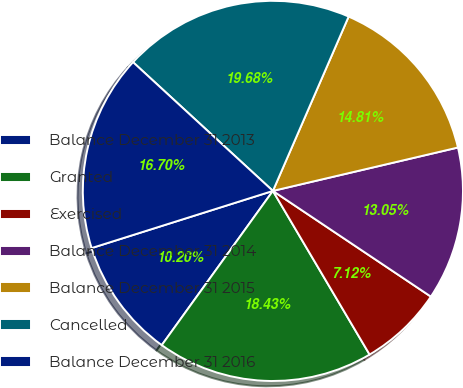Convert chart. <chart><loc_0><loc_0><loc_500><loc_500><pie_chart><fcel>Balance December 31 2013<fcel>Granted<fcel>Exercised<fcel>Balance December 31 2014<fcel>Balance December 31 2015<fcel>Cancelled<fcel>Balance December 31 2016<nl><fcel>10.2%<fcel>18.43%<fcel>7.12%<fcel>13.05%<fcel>14.81%<fcel>19.68%<fcel>16.7%<nl></chart> 